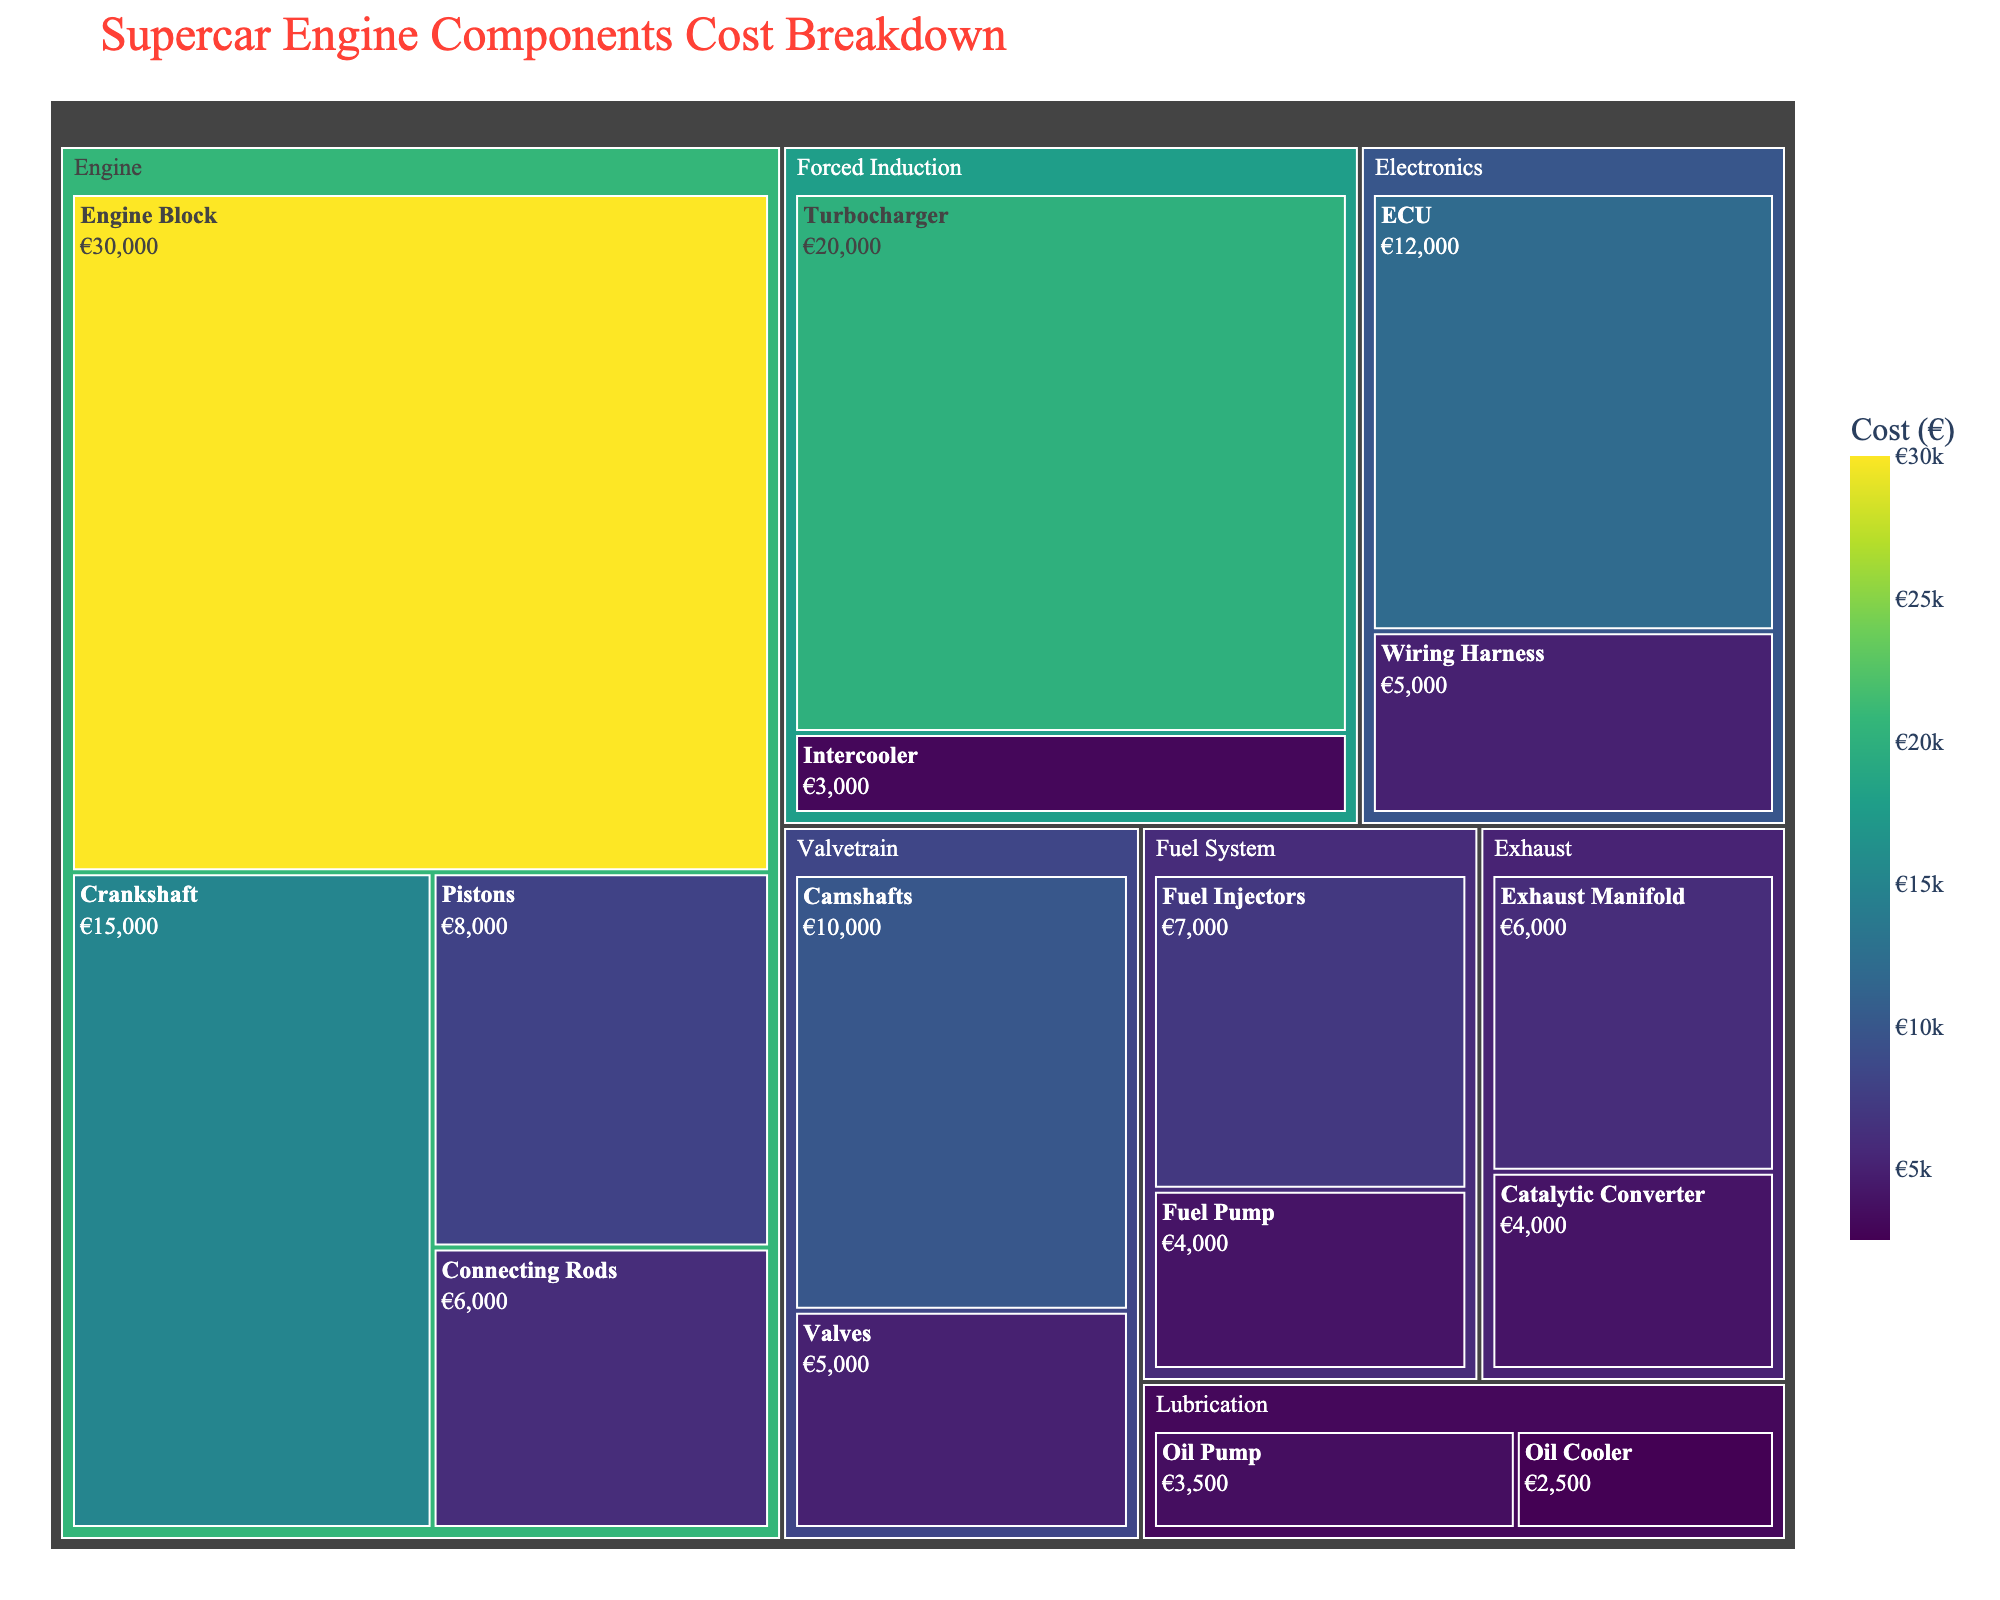What's the most expensive component in the figure? The figure visually shows the Engine Block as having the largest area and the highest cost, based on the colors and text displayed.
Answer: Engine Block What category does the Turbocharger belong to? The Turbocharger is grouped within the 'Forced Induction' category in the treemap, indicated by the hierarchical structure of the visualization.
Answer: Forced Induction Which component is more expensive, the ECU or the camshafts? Looking at the color intensity and the values shown for each component in the Electronics and Valvetrain categories, the ECU costs €12,000 while the camshafts cost €10,000.
Answer: ECU What is the combined cost of the Fuel Pump and the Oil Pump? Adding the values shown for the Fuel Pump (€4000) and the Oil Pump (€3500) in their respective categories gives a combined cost of €7500.
Answer: €7500 Which category has the highest total cost? Summing the costs of each component within each category reveals that the Engine category has the highest total, dominated by the costs of the Engine Block, Crankshaft, Pistons, and Connecting Rods.
Answer: Engine What component in the Fuel System category has a higher cost than the Fuel Pump? By comparing the costs within the Fuel System category, the Fuel Injectors (€7000) are more expensive than the Fuel Pump (€4000).
Answer: Fuel Injectors How much more expensive is the Turbocharger compared to the Intercooler? Subtracting the cost of the Intercooler (€3000) from the cost of the Turbocharger (€20000), the difference is €17000.
Answer: €17000 In which category do Oil Pump and Oil Cooler belong? Both the Oil Pump and Oil Cooler are grouped within the Lubrication category, as indicated by their hierarchical grouping in the treemap.
Answer: Lubrication Which component from the Exhaust category costs €6000? The Exhaust category's components are displayed with their costs, showing that the Exhaust Manifold is priced at €6000.
Answer: Exhaust Manifold 